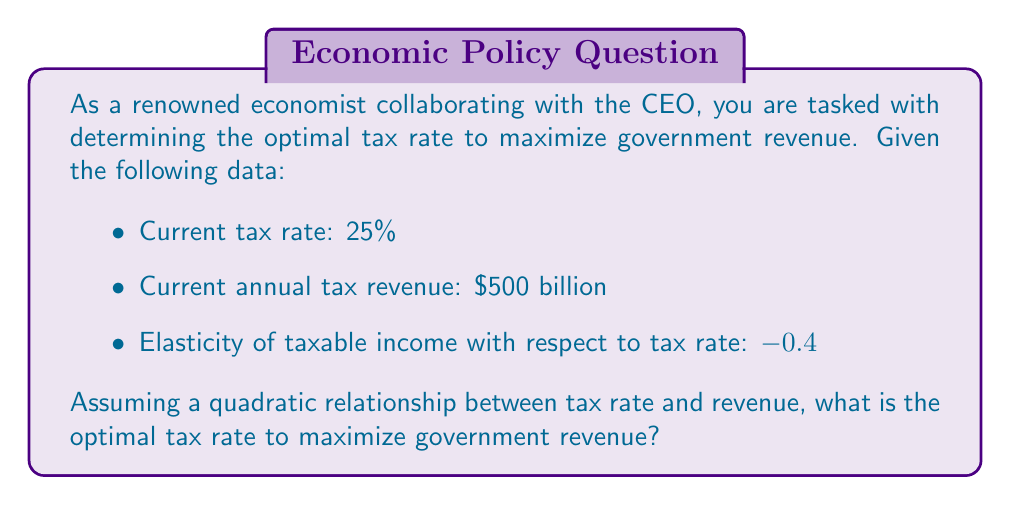Show me your answer to this math problem. To solve this inverse problem, we'll follow these steps:

1) Let $R$ be the revenue and $t$ be the tax rate. We assume a quadratic relationship:

   $$R = at^2 + bt + c$$

2) The current situation gives us one point on this curve: $(0.25, 500)$

3) The elasticity of taxable income with respect to tax rate is given as -0.4. Elasticity is defined as:

   $$\epsilon = \frac{\partial(\text{Taxable Income})}{\partial t} \cdot \frac{t}{\text{Taxable Income}}$$

4) Revenue is tax rate times taxable income. So, $\frac{\partial R}{\partial t} = \text{Taxable Income} + t \cdot \frac{\partial(\text{Taxable Income})}{\partial t}$

5) Rearranging this and using the elasticity definition:

   $$\frac{\partial R}{\partial t} = \text{Taxable Income} \cdot (1 + \epsilon)$$

6) At the current point, $\text{Taxable Income} = \frac{500}{0.25} = 2000$, so:

   $$\frac{\partial R}{\partial t}\bigg|_{t=0.25} = 2000 \cdot (1 + (-0.4)) = 1200$$

7) For our quadratic function, $\frac{\partial R}{\partial t} = 2at + b$. At $t=0.25$:

   $$2a(0.25) + b = 1200$$

8) The revenue at $t=0.25$ is 500, so:

   $$a(0.25)^2 + b(0.25) + c = 500$$

9) The optimal tax rate occurs where $\frac{\partial R}{\partial t} = 0$, i.e., where $2at + b = 0$ or $t = -\frac{b}{2a}$

10) Solving these equations simultaneously:

    $$a = -9600, b = 3600, c = 162.5$$

11) The optimal tax rate is thus:

    $$t_{\text{optimal}} = -\frac{b}{2a} = -\frac{3600}{2(-9600)} = 0.1875$$
Answer: 18.75% 